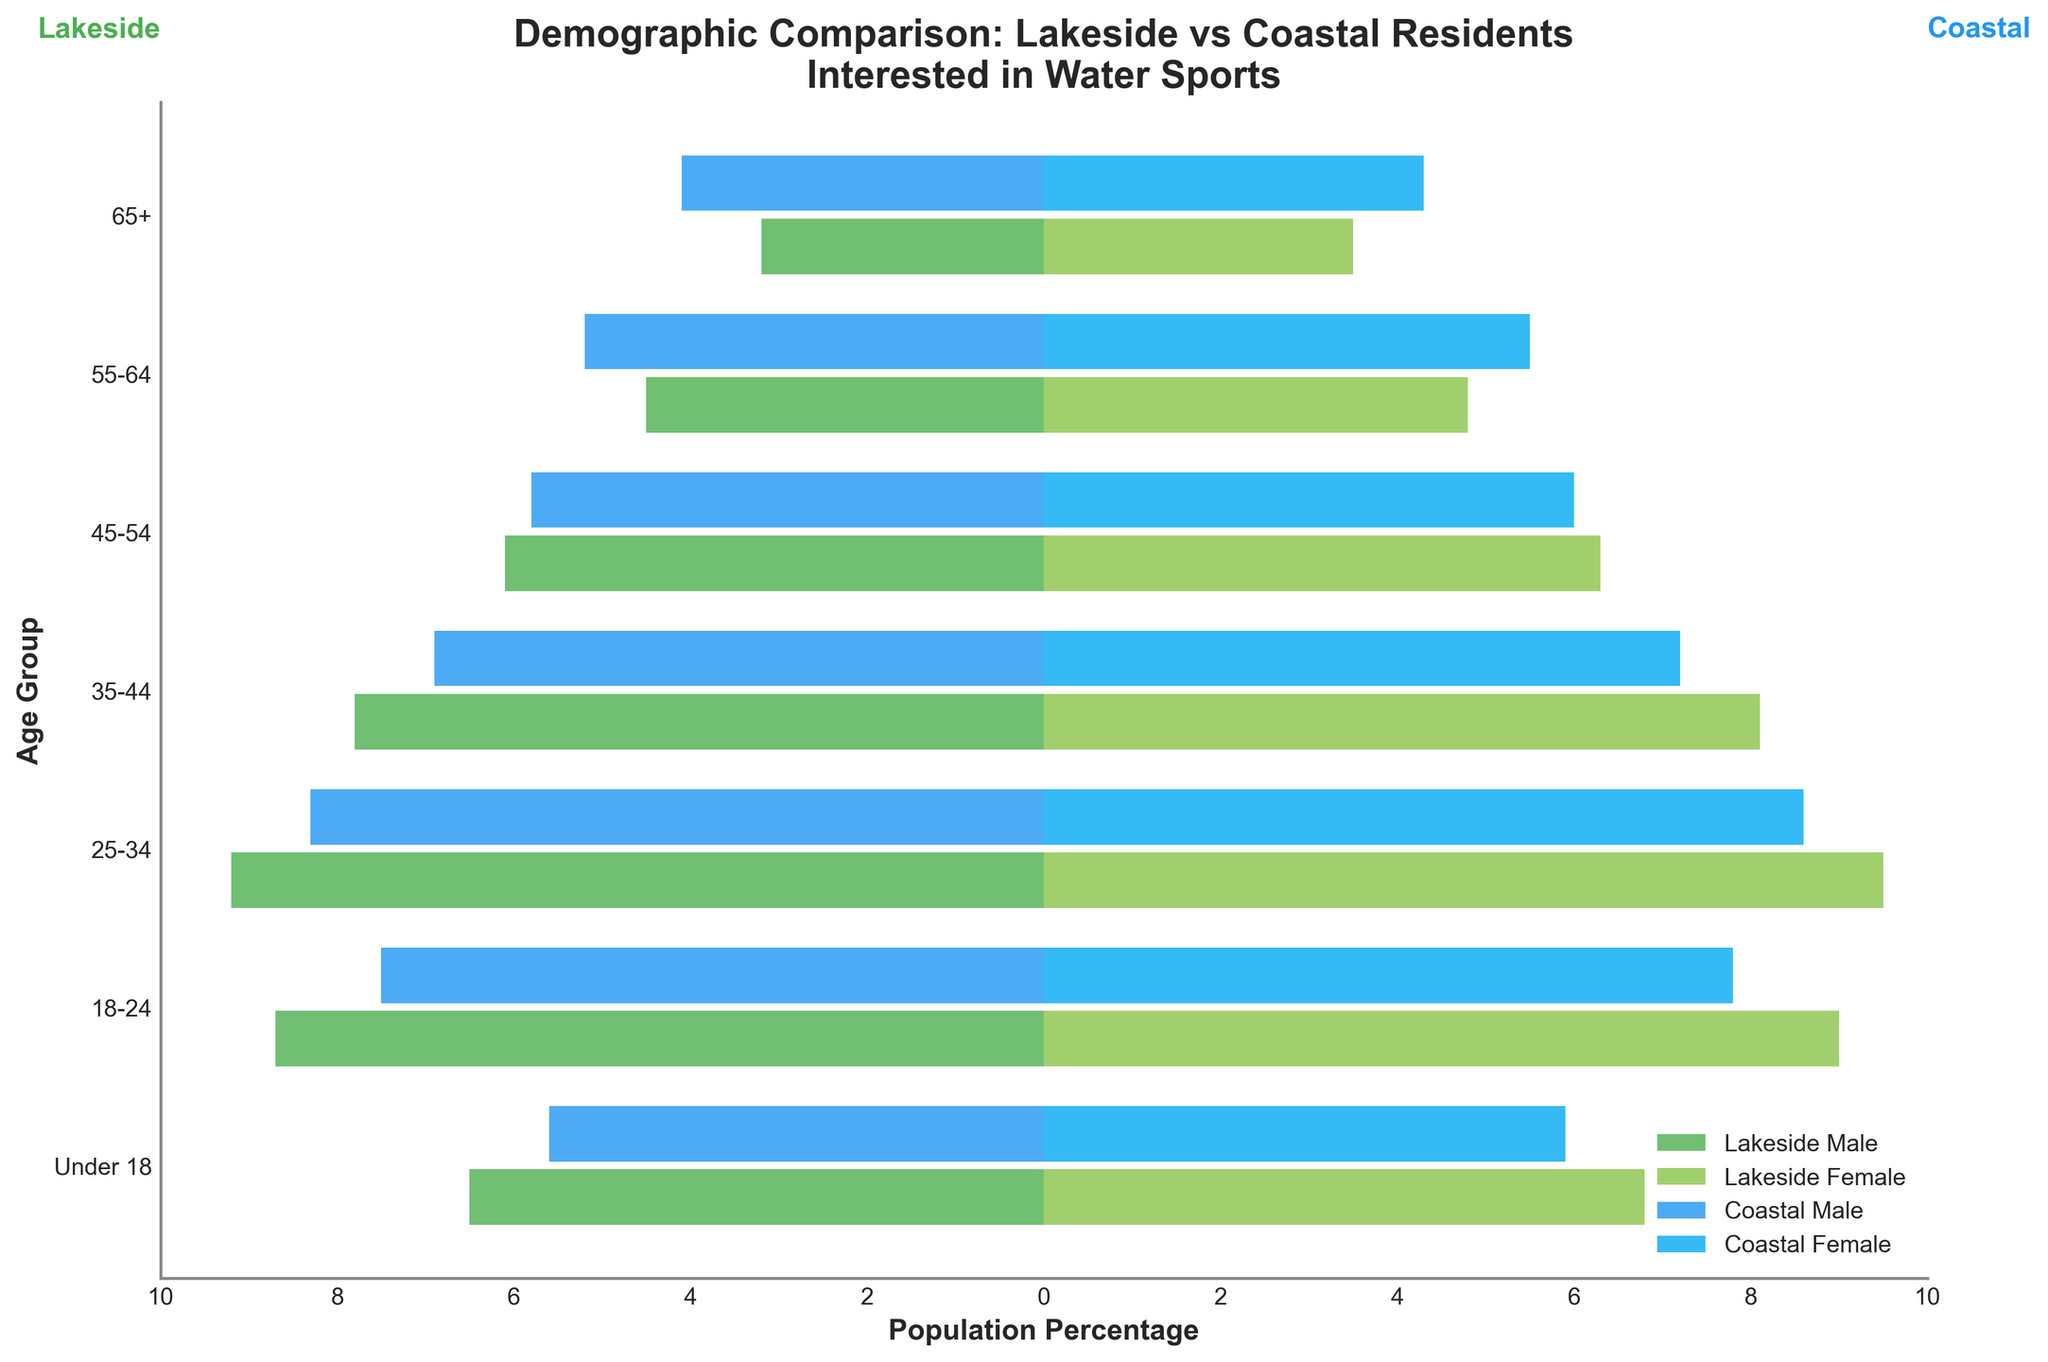What is the title of the figure? The title is usually displayed at the top of the figure and summarizes the content of the visual. In this case, the title indicates a demographic comparison.
Answer: Demographic Comparison: Lakeside vs Coastal Residents Interested in Water Sports What is the age group with the highest percentage of lakeside female residents? Looking at the bars representing lakeside females, the age group with the longest bar indicates the highest percentage.
Answer: 25-34 Which gender has a higher population percentage in the coastal 18-24 age group? Compare the bar lengths for coastal male and coastal female in the 18-24 age group. The longer bar represents the higher percentage.
Answer: Coastal Female How does the percentage of lakeside residents under 18 compare to coastal residents in the same age group? Compare the lengths of the bars for lakeside male and female under 18 with those for coastal male and female under 18.
Answer: Lakeside residents have a higher percentage What is the approximate total percentage of lakeside males aged 55-64 and 65+? Add the percentages for lakeside males in the 55-64 and 65+ age groups: 4.5 + 3.2.
Answer: 7.7 Which coastal age group has the smallest difference between males and females? For each coastal age group, calculate the absolute difference between the male and female percentages and compare the results.
Answer: 45-54 What is the combined percentage of lakeside and coastal females in the 35-44 age group? Add the percentages for lakeside and coastal females in the 35-44 age group: 8.1 + 7.2.
Answer: 15.3 What is the most represented age group among both lakeside and coastal males? Identify the age group with the highest absolute value in the negative percentage bars for both lakeside and coastal males.
Answer: 25-34 In which age group is the gender disparity largest for coastal residents? Calculate the absolute differences between males and females across all coastal age groups and find the largest difference.
Answer: 25-34 How do the percentages of lakeside females aged 25-34 and coastal females aged 25-34 compare? Compare the bar lengths for lakeside females and coastal females in the 25-34 age group.
Answer: Lakeside females have a higher percentage 